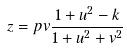<formula> <loc_0><loc_0><loc_500><loc_500>z = p v \frac { 1 + u ^ { 2 } - k } { 1 + u ^ { 2 } + v ^ { 2 } }</formula> 